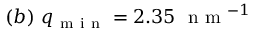<formula> <loc_0><loc_0><loc_500><loc_500>( b ) \ q _ { m i n } = 2 . 3 5 \ n m ^ { - 1 }</formula> 